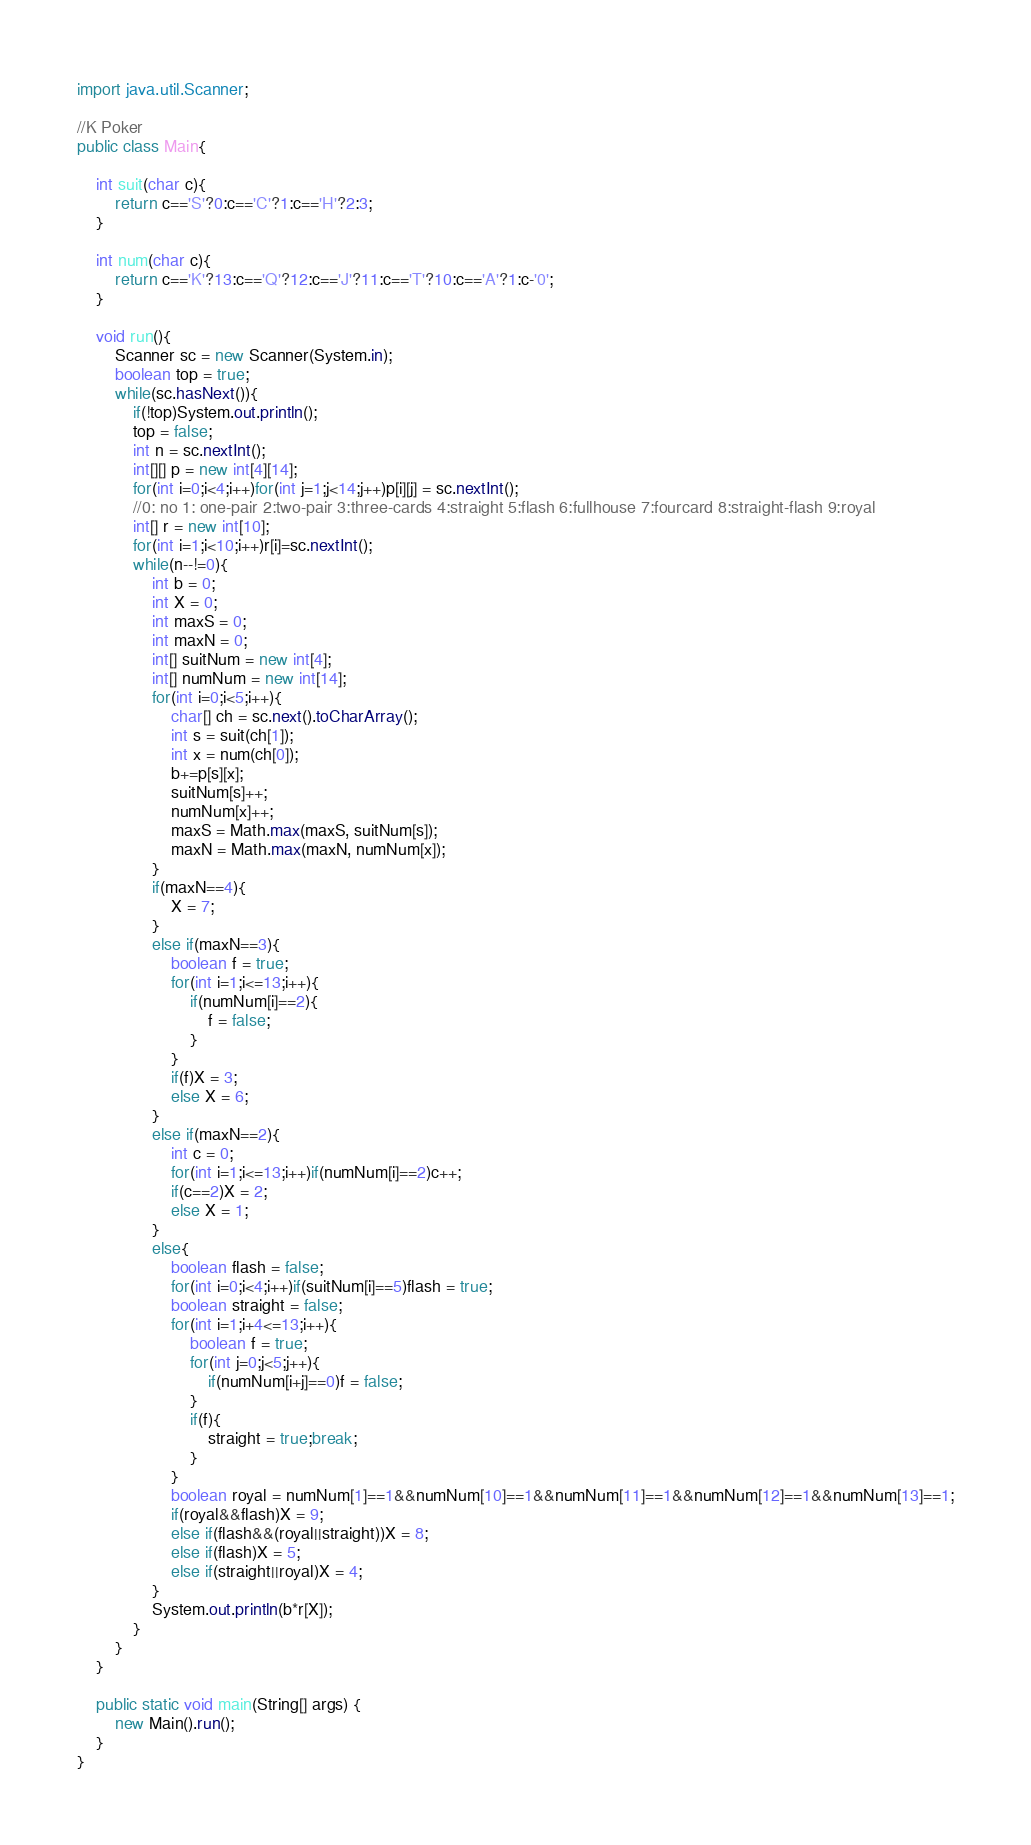Convert code to text. <code><loc_0><loc_0><loc_500><loc_500><_Java_>import java.util.Scanner;

//K Poker
public class Main{

	int suit(char c){
		return c=='S'?0:c=='C'?1:c=='H'?2:3;
	}
	
	int num(char c){
		return c=='K'?13:c=='Q'?12:c=='J'?11:c=='T'?10:c=='A'?1:c-'0';
	}
	
	void run(){
		Scanner sc = new Scanner(System.in);
		boolean top = true;
		while(sc.hasNext()){
			if(!top)System.out.println();
			top = false;
			int n = sc.nextInt();
			int[][] p = new int[4][14];
			for(int i=0;i<4;i++)for(int j=1;j<14;j++)p[i][j] = sc.nextInt();
			//0: no 1: one-pair 2:two-pair 3:three-cards 4:straight 5:flash 6:fullhouse 7:fourcard 8:straight-flash 9:royal
			int[] r = new int[10];
			for(int i=1;i<10;i++)r[i]=sc.nextInt();
			while(n--!=0){
				int b = 0;
				int X = 0;
				int maxS = 0;
				int maxN = 0;
				int[] suitNum = new int[4];
				int[] numNum = new int[14];
				for(int i=0;i<5;i++){
					char[] ch = sc.next().toCharArray();
					int s = suit(ch[1]);
					int x = num(ch[0]);
					b+=p[s][x];
					suitNum[s]++;
					numNum[x]++;
					maxS = Math.max(maxS, suitNum[s]);
					maxN = Math.max(maxN, numNum[x]);
				}
				if(maxN==4){
					X = 7;
				}
				else if(maxN==3){
					boolean f = true;
					for(int i=1;i<=13;i++){
						if(numNum[i]==2){
							f = false;
						}
					}
					if(f)X = 3;
					else X = 6;
				}
				else if(maxN==2){
					int c = 0;
					for(int i=1;i<=13;i++)if(numNum[i]==2)c++;
					if(c==2)X = 2;
					else X = 1;
				}
				else{
					boolean flash = false;
					for(int i=0;i<4;i++)if(suitNum[i]==5)flash = true;
					boolean straight = false;
					for(int i=1;i+4<=13;i++){
						boolean f = true;
						for(int j=0;j<5;j++){
							if(numNum[i+j]==0)f = false;
						}
						if(f){
							straight = true;break;
						}
					}
					boolean royal = numNum[1]==1&&numNum[10]==1&&numNum[11]==1&&numNum[12]==1&&numNum[13]==1;
					if(royal&&flash)X = 9;
					else if(flash&&(royal||straight))X = 8;
					else if(flash)X = 5;
					else if(straight||royal)X = 4;
				}
				System.out.println(b*r[X]);
			}
		}
	}
	
	public static void main(String[] args) {
		new Main().run();
	}
}</code> 